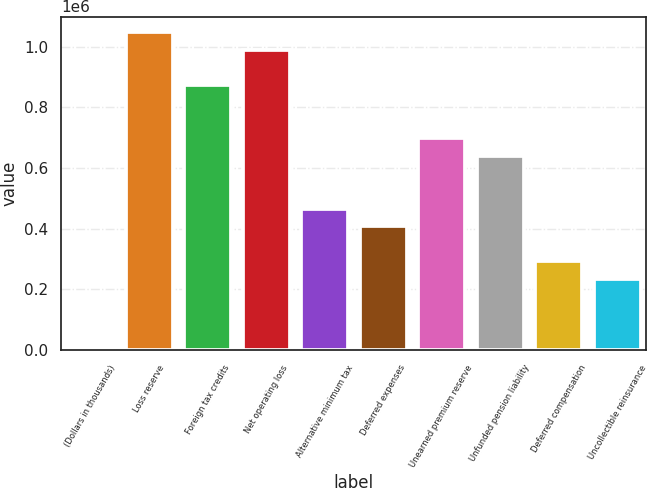Convert chart to OTSL. <chart><loc_0><loc_0><loc_500><loc_500><bar_chart><fcel>(Dollars in thousands)<fcel>Loss reserve<fcel>Foreign tax credits<fcel>Net operating loss<fcel>Alternative minimum tax<fcel>Deferred expenses<fcel>Unearned premium reserve<fcel>Unfunded pension liability<fcel>Deferred compensation<fcel>Uncollectible reinsurance<nl><fcel>2011<fcel>1.0467e+06<fcel>872584<fcel>988660<fcel>466317<fcel>408278<fcel>698469<fcel>640431<fcel>292202<fcel>234164<nl></chart> 